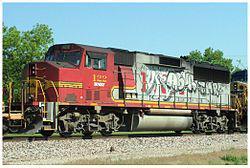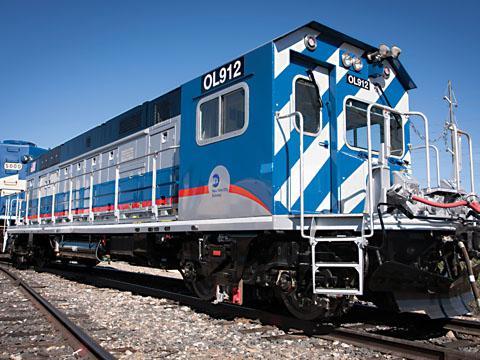The first image is the image on the left, the second image is the image on the right. Analyze the images presented: Is the assertion "more then two train cars are being shown in the right side image" valid? Answer yes or no. No. The first image is the image on the left, the second image is the image on the right. Considering the images on both sides, is "There is 1 train on a track facing right in the right image." valid? Answer yes or no. Yes. 